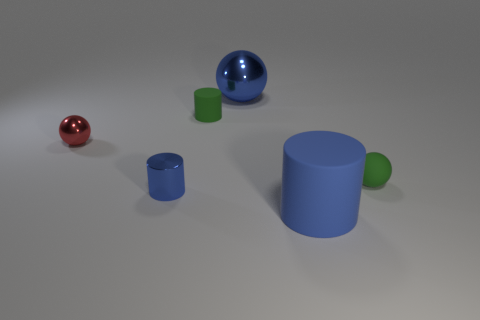Add 1 tiny rubber objects. How many objects exist? 7 Subtract 1 green spheres. How many objects are left? 5 Subtract all small blue shiny cylinders. Subtract all blue metal balls. How many objects are left? 4 Add 1 tiny shiny things. How many tiny shiny things are left? 3 Add 6 green matte cylinders. How many green matte cylinders exist? 7 